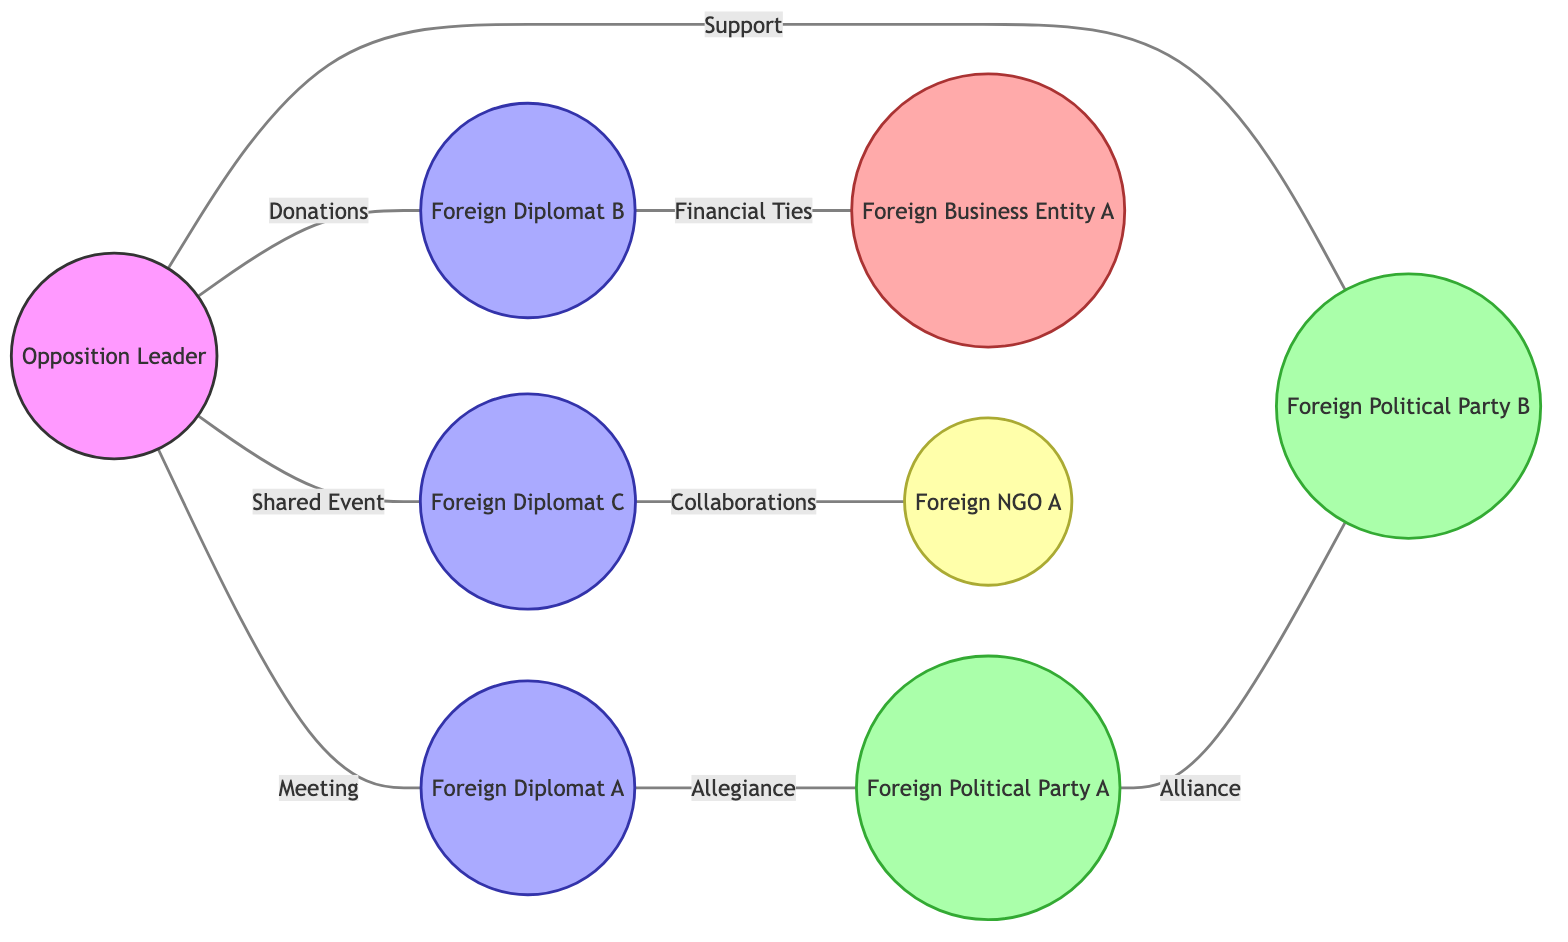What is the relationship between the Opposition Leader and Foreign Diplomat A? The diagram indicates a 'Meeting' relationship between the Opposition Leader and Foreign Diplomat A, as shown by the edge labeled 'Meeting' connecting them.
Answer: Meeting How many Foreign Diplomats are connected to the Opposition Leader? Referring to the edges connected to the Opposition Leader, there are three 'Foreign Diplomats' (Foreign Diplomat A, Foreign Diplomat B, and Foreign Diplomat C) directly connected.
Answer: 3 What type of connection does Foreign Diplomat B have with Business Entity A? The diagram displays a 'Financial Ties' connection between Foreign Diplomat B and Business Entity A, signified by the edge labeled 'Financial Ties.'
Answer: Financial Ties Which Foreign Political Party does the Opposition Leader support? The connection shown in the diagram indicates that the Opposition Leader supports 'Foreign Political Party B,' as represented by the edge labeled 'Support' linking them.
Answer: Foreign Political Party B Is there an alliance between Foreign Political Party A and Foreign Political Party B? The diagram shows an 'Alliance' connection between Foreign Political Party A and Foreign Political Party B, as illustrated by the edge labeled 'Alliance.'
Answer: Yes What are the types of entities connected to Foreign Diplomat C? Evaluating the connections from Foreign Diplomat C, it can be seen that there is one connection to NGO A indicated by the edge labeled 'Collaborations.' Therefore, the type of entity is 'NGO.'
Answer: NGO What is the total number of edges in the graph? Counting all connections, each labeled edge in the diagram represents a relationship. There are a total of eight edges depicted in this graph.
Answer: 8 Which Foreign Diplomat is associated with an 'Allegiance' to Foreign Political Party A? According to the diagram, Foreign Diplomat A is associated with an 'Allegiance' to Foreign Political Party A, as denoted by the edge labeled 'Allegiance.'
Answer: Foreign Diplomat A What label describes the connection between the Opposition Leader and Foreign Diplomat C? The diagram exhibits a connection labeled 'Shared Event' between the Opposition Leader and Foreign Diplomat C, represented by the corresponding edge.
Answer: Shared Event 